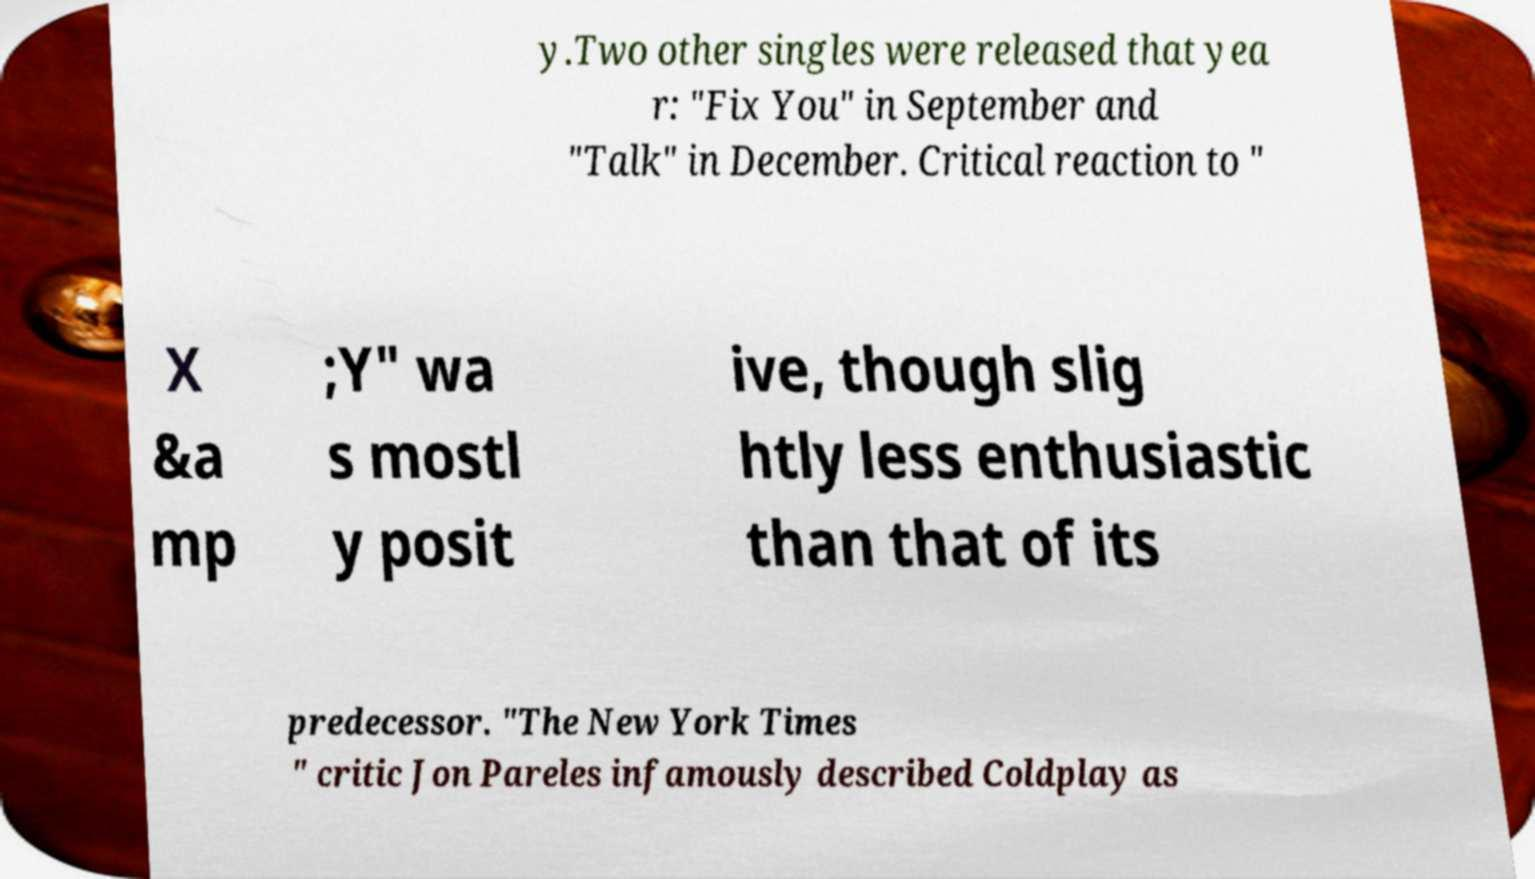Could you assist in decoding the text presented in this image and type it out clearly? y.Two other singles were released that yea r: "Fix You" in September and "Talk" in December. Critical reaction to " X &a mp ;Y" wa s mostl y posit ive, though slig htly less enthusiastic than that of its predecessor. "The New York Times " critic Jon Pareles infamously described Coldplay as 